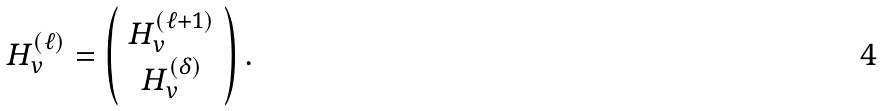Convert formula to latex. <formula><loc_0><loc_0><loc_500><loc_500>H _ { v } ^ { ( \ell ) } = \left ( \begin{array} { c } H _ { v } ^ { ( \ell + 1 ) } \\ H _ { v } ^ { ( \delta ) } \\ \end{array} \right ) .</formula> 